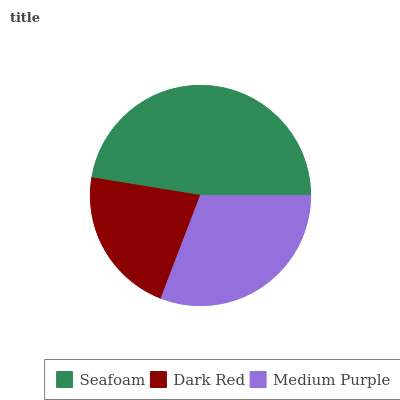Is Dark Red the minimum?
Answer yes or no. Yes. Is Seafoam the maximum?
Answer yes or no. Yes. Is Medium Purple the minimum?
Answer yes or no. No. Is Medium Purple the maximum?
Answer yes or no. No. Is Medium Purple greater than Dark Red?
Answer yes or no. Yes. Is Dark Red less than Medium Purple?
Answer yes or no. Yes. Is Dark Red greater than Medium Purple?
Answer yes or no. No. Is Medium Purple less than Dark Red?
Answer yes or no. No. Is Medium Purple the high median?
Answer yes or no. Yes. Is Medium Purple the low median?
Answer yes or no. Yes. Is Seafoam the high median?
Answer yes or no. No. Is Dark Red the low median?
Answer yes or no. No. 